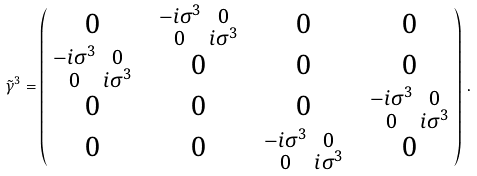Convert formula to latex. <formula><loc_0><loc_0><loc_500><loc_500>\, \tilde { \gamma } ^ { 3 } = \begin{pmatrix} 0 & \begin{smallmatrix} - i \sigma ^ { 3 } & 0 \\ 0 & i \sigma ^ { 3 } \end{smallmatrix} & 0 & 0 \\ \begin{smallmatrix} - i \sigma ^ { 3 } & 0 \\ 0 & i \sigma ^ { 3 } \end{smallmatrix} & 0 & 0 & 0 \\ 0 & 0 & 0 & \begin{smallmatrix} - i \sigma ^ { 3 } & 0 \\ 0 & i \sigma ^ { 3 } \end{smallmatrix} \\ 0 & 0 & \begin{smallmatrix} - i \sigma ^ { 3 } & 0 \\ 0 & i \sigma ^ { 3 } \end{smallmatrix} & 0 \end{pmatrix} \, .</formula> 